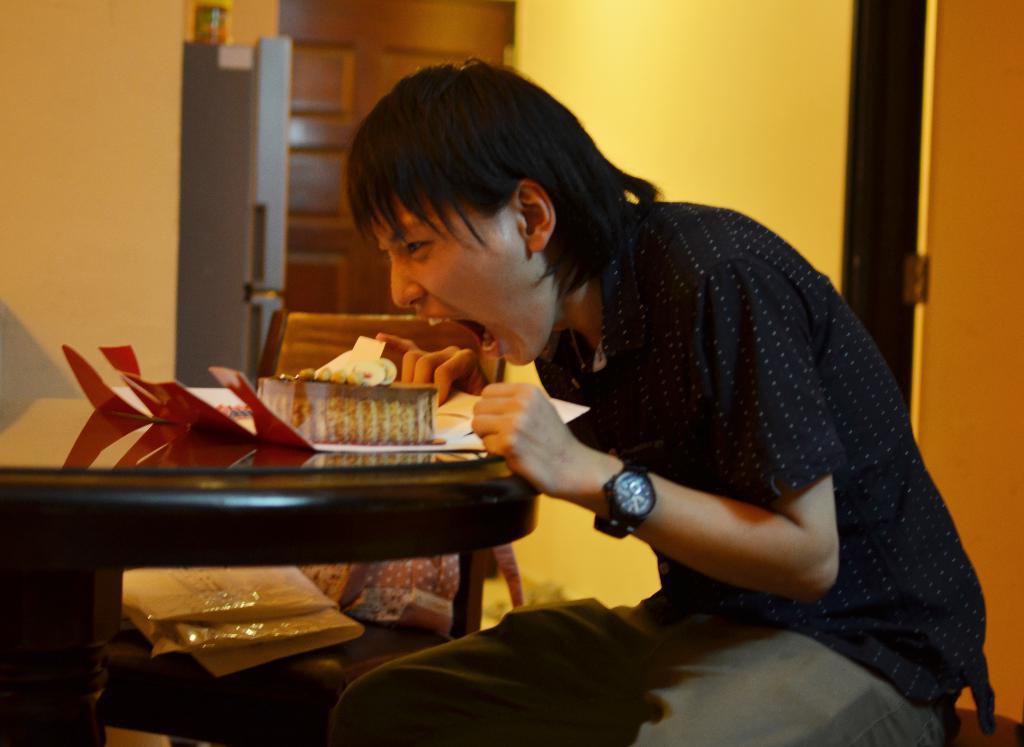In one or two sentences, can you explain what this image depicts? In this image I can see a person wearing shirt, trouser, sitting on the chair, facing towards the left side and eating a cake which is placed on a table. I can see a watch to his left hand. Beside this person there is another table on which few objects are placed. In the background, I can see the wall and a door and also there is a refrigerator on which a box is placed. 